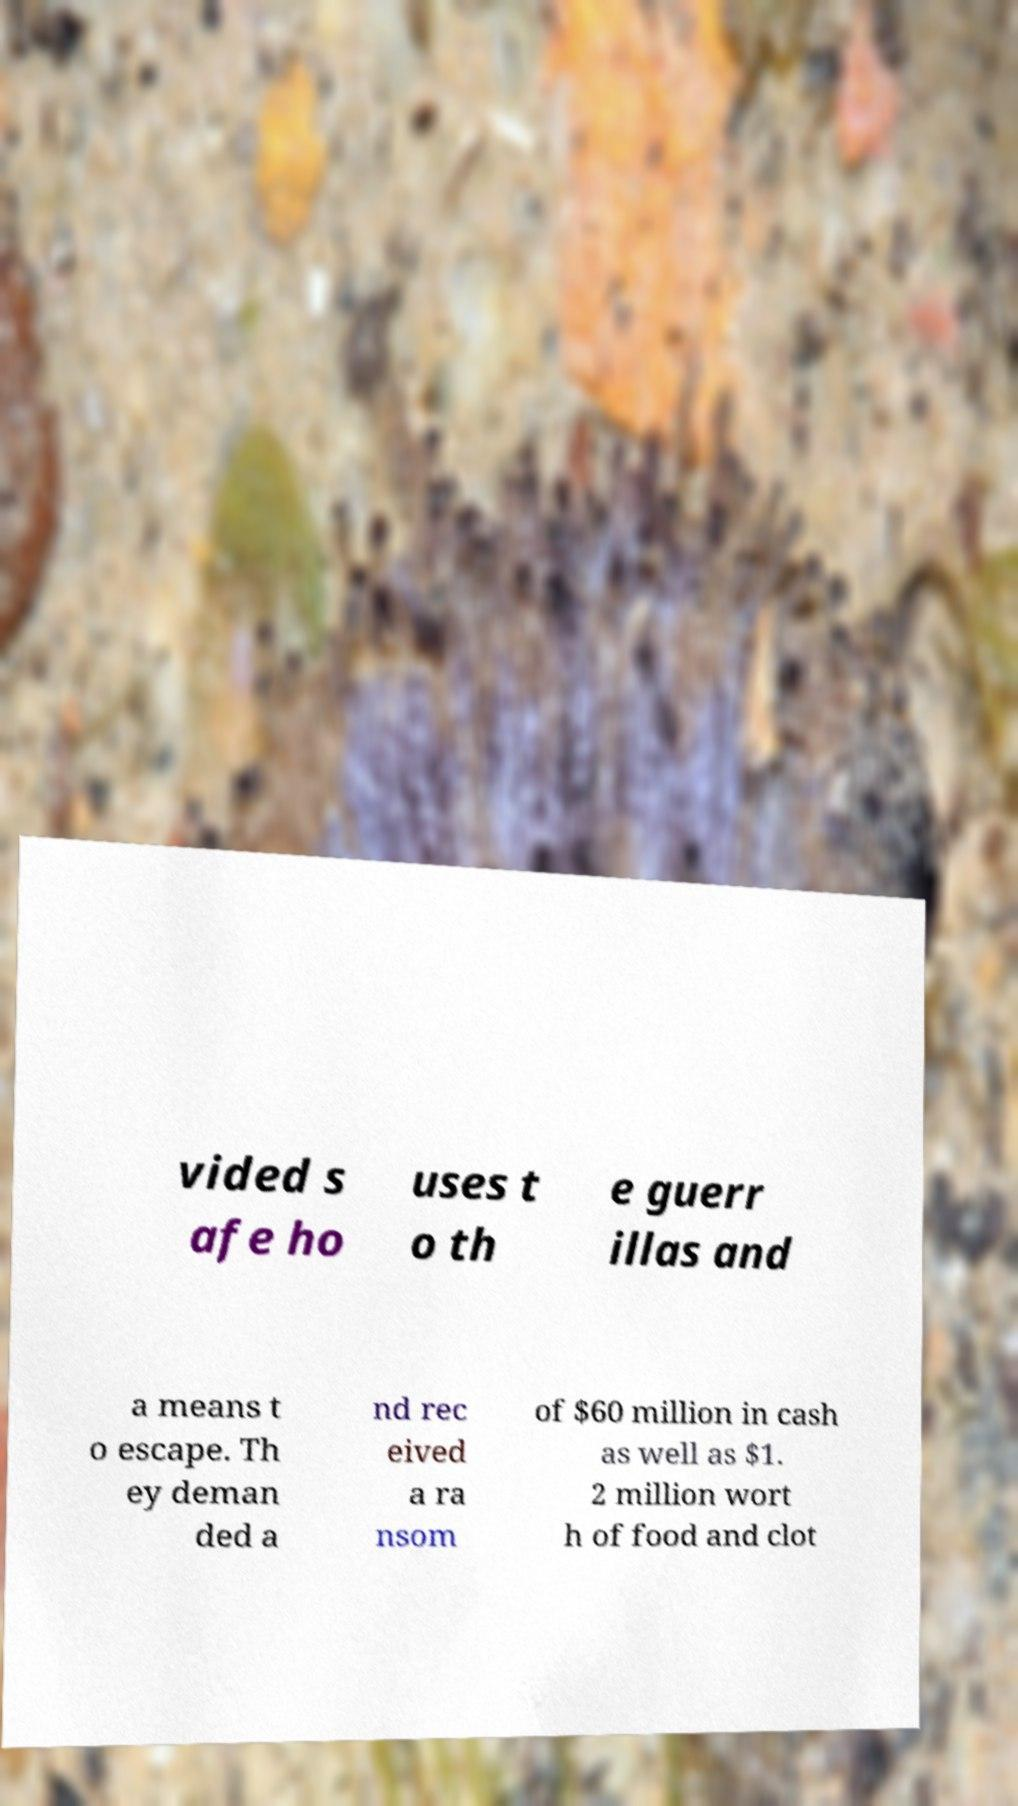Please identify and transcribe the text found in this image. vided s afe ho uses t o th e guerr illas and a means t o escape. Th ey deman ded a nd rec eived a ra nsom of $60 million in cash as well as $1. 2 million wort h of food and clot 